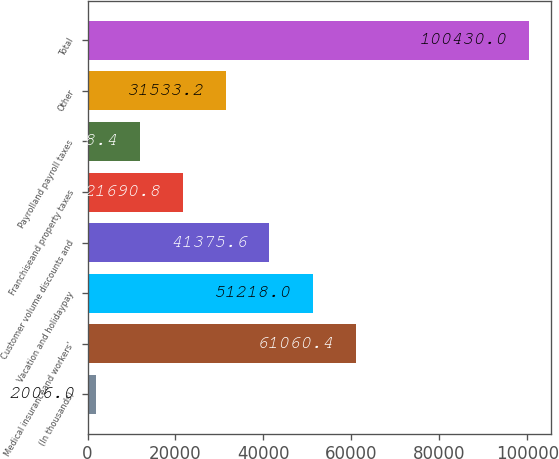Convert chart. <chart><loc_0><loc_0><loc_500><loc_500><bar_chart><fcel>(In thousands)<fcel>Medical insuranceand workers'<fcel>Vacation and holidaypay<fcel>Customer volume discounts and<fcel>Franchiseand property taxes<fcel>Payrolland payroll taxes<fcel>Other<fcel>Total<nl><fcel>2006<fcel>61060.4<fcel>51218<fcel>41375.6<fcel>21690.8<fcel>11848.4<fcel>31533.2<fcel>100430<nl></chart> 